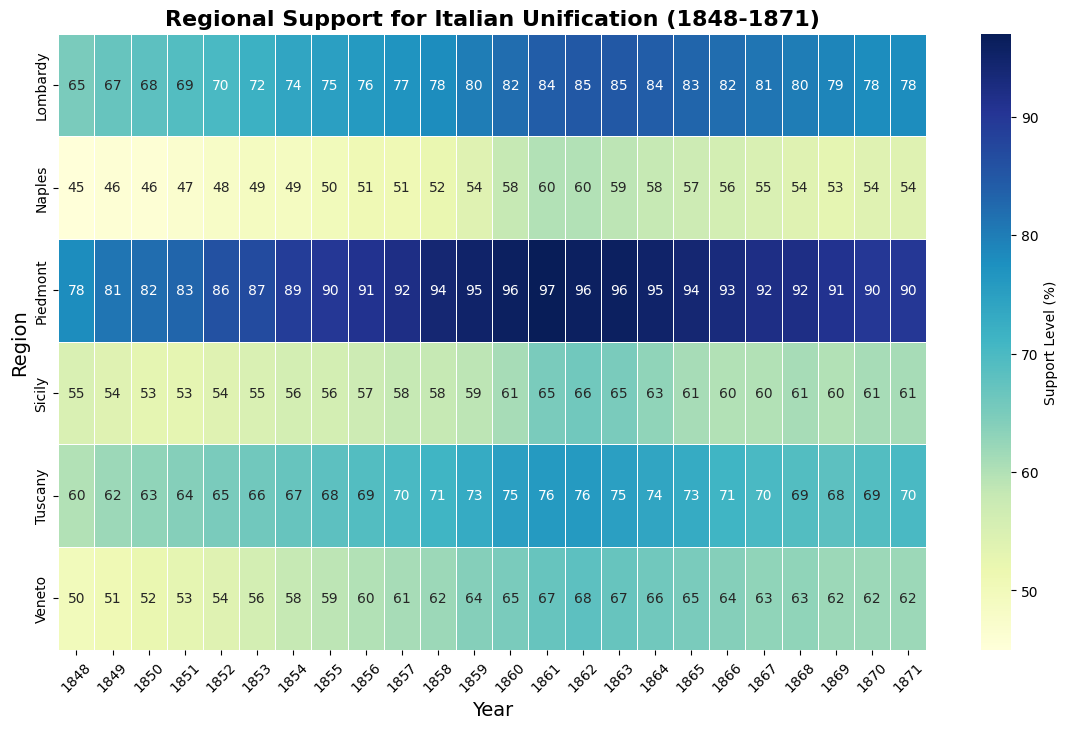Which region had the highest level of support for unification in 1861? Looking at the heatmap for the year 1861, identify the region with the highest numerical value. Piedmont shows the highest support level at 97%.
Answer: Piedmont Which region had the lowest level of support for unification in 1848? Observe the support levels for the year 1848. The region with the lowest numerical value is Naples with a support level of 45%.
Answer: Naples What is the overall trend of support in Piedmont from 1848 to 1871? Examine the trend line in the heatmap for Piedmont. Support levels generally increase from 1848 to 1861 and then gradually decrease slightly towards 1871.
Answer: Increasing initially, then decreasing Compare the support levels in Venice and Tuscany in 1854. Which region had a higher support level? Check the values for both Venice and Tuscany in 1854. Venice had a support level of 58%, whereas Tuscany had 67%. Therefore, Tuscany had higher support.
Answer: Tuscany What is the average support level for unification in Lombardy from 1850 to 1860? Sum the support levels in Lombardy for each year from 1850 to 1860 and divide by the number of years. (68 + 69 + 70 + 72 + 74 + 75 + 76 + 77 + 78 + 80 + 82) = 821, then 821/11 ≈ 74.64.
Answer: ~74.64 Which year saw a dramatic increase in support in Sicily? Identify significant jumps in the support levels in the Sicily row across years. The most noticeable increase occurs between 1859 (59%) and 1861 (65%).
Answer: 1860 Which region had a more consistent support level, Sicily or Tuscany, from 1865 to 1871? Compare the support levels from 1865 to 1871 for both regions. Sicily’s support levels are relatively stable around 60-61%, whereas Tuscany’s levels vary (71, 70, 69, 68, 69, 70). Thus, Sicily had a more consistent level of support.
Answer: Sicily What is the difference in support for unification between Naples and Lombardy in 1871? Compare the support levels for both Naples and Lombardy in 1871. Naples has a support level of 54 and Lombardy has 78. The difference is 78 - 54 = 24.
Answer: 24 How did the support level in Veneto change from 1860 to 1870? Examine the values for Veneto in the heatmap from 1860 to 1870. Support drops slightly from 65 (1860) to 62 (1870).
Answer: Decreased by 3 points Which regions had a peak support level for unification in 1861? Check which regions had the highest value in 1861 within their respective rows. Both Piedmont (97) and Sicily (65) had their peak support in 1861.
Answer: Piedmont and Sicily 